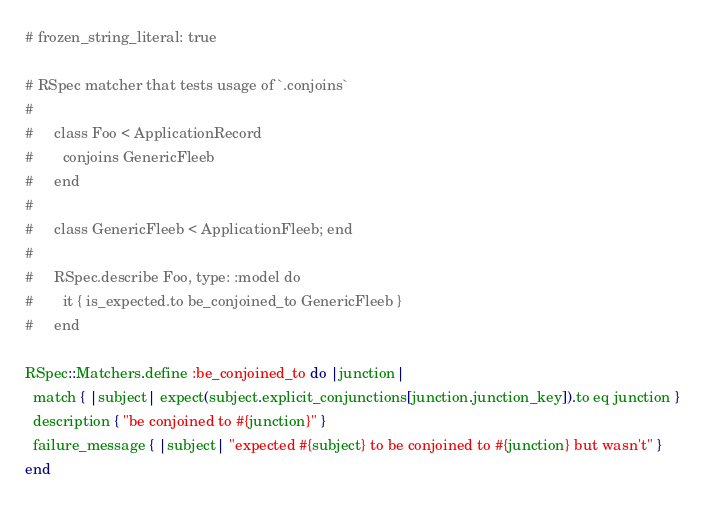<code> <loc_0><loc_0><loc_500><loc_500><_Ruby_># frozen_string_literal: true

# RSpec matcher that tests usage of `.conjoins`
#
#     class Foo < ApplicationRecord
#       conjoins GenericFleeb
#     end
#
#     class GenericFleeb < ApplicationFleeb; end
#
#     RSpec.describe Foo, type: :model do
#       it { is_expected.to be_conjoined_to GenericFleeb }
#     end

RSpec::Matchers.define :be_conjoined_to do |junction|
  match { |subject| expect(subject.explicit_conjunctions[junction.junction_key]).to eq junction }
  description { "be conjoined to #{junction}" }
  failure_message { |subject| "expected #{subject} to be conjoined to #{junction} but wasn't" }
end
</code> 